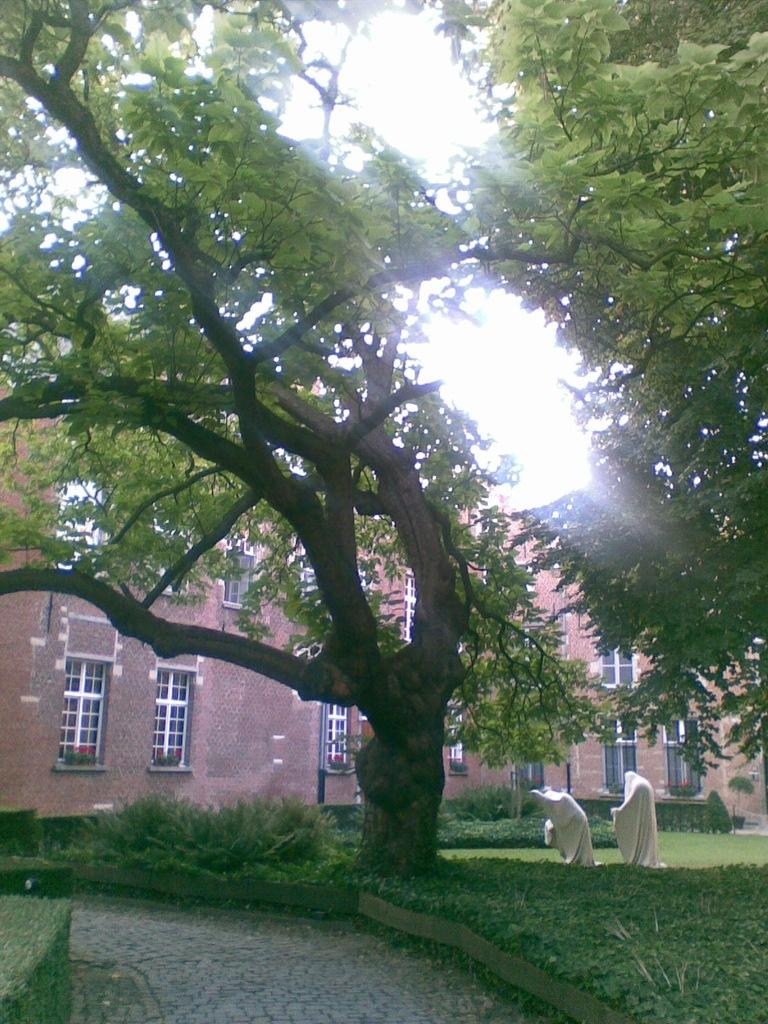What is the main feature in the garden in the image? There is a huge tree in the middle of the garden. What can be seen behind the tree in the image? There is a brown color brick building behind the tree. What type of windows are on the building? The building has white color glass windows. Where is the sofa located in the image? There is no sofa present in the image. What type of flame can be seen coming from the tree in the image? There is no flame present in the image; it is a tree in a garden. 